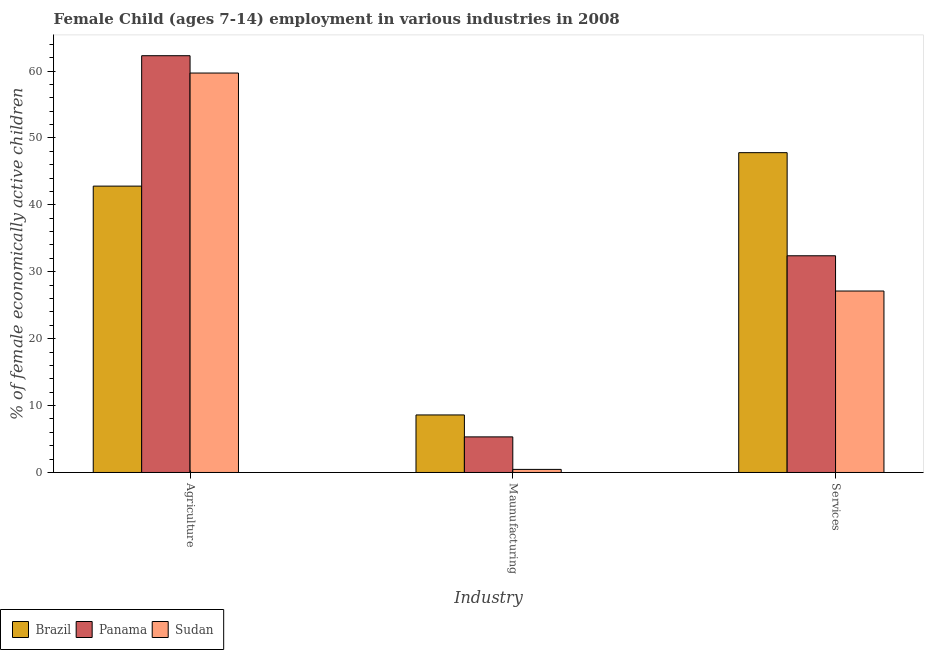How many different coloured bars are there?
Your response must be concise. 3. Are the number of bars on each tick of the X-axis equal?
Provide a short and direct response. Yes. How many bars are there on the 1st tick from the right?
Give a very brief answer. 3. What is the label of the 1st group of bars from the left?
Your response must be concise. Agriculture. What is the percentage of economically active children in services in Sudan?
Make the answer very short. 27.12. Across all countries, what is the maximum percentage of economically active children in manufacturing?
Offer a terse response. 8.6. Across all countries, what is the minimum percentage of economically active children in manufacturing?
Give a very brief answer. 0.46. In which country was the percentage of economically active children in manufacturing minimum?
Offer a very short reply. Sudan. What is the total percentage of economically active children in agriculture in the graph?
Your answer should be compact. 164.79. What is the difference between the percentage of economically active children in manufacturing in Sudan and that in Brazil?
Make the answer very short. -8.14. What is the difference between the percentage of economically active children in services in Brazil and the percentage of economically active children in manufacturing in Panama?
Your answer should be very brief. 42.48. What is the average percentage of economically active children in services per country?
Ensure brevity in your answer.  35.77. What is the difference between the percentage of economically active children in manufacturing and percentage of economically active children in agriculture in Brazil?
Provide a short and direct response. -34.2. What is the ratio of the percentage of economically active children in manufacturing in Sudan to that in Panama?
Provide a short and direct response. 0.09. Is the difference between the percentage of economically active children in agriculture in Sudan and Brazil greater than the difference between the percentage of economically active children in services in Sudan and Brazil?
Your answer should be very brief. Yes. What is the difference between the highest and the second highest percentage of economically active children in agriculture?
Ensure brevity in your answer.  2.59. What is the difference between the highest and the lowest percentage of economically active children in manufacturing?
Offer a terse response. 8.14. In how many countries, is the percentage of economically active children in manufacturing greater than the average percentage of economically active children in manufacturing taken over all countries?
Your answer should be very brief. 2. What does the 2nd bar from the right in Services represents?
Give a very brief answer. Panama. Is it the case that in every country, the sum of the percentage of economically active children in agriculture and percentage of economically active children in manufacturing is greater than the percentage of economically active children in services?
Provide a succinct answer. Yes. How many bars are there?
Ensure brevity in your answer.  9. What is the difference between two consecutive major ticks on the Y-axis?
Make the answer very short. 10. Does the graph contain any zero values?
Offer a terse response. No. Where does the legend appear in the graph?
Your answer should be very brief. Bottom left. How many legend labels are there?
Make the answer very short. 3. What is the title of the graph?
Offer a very short reply. Female Child (ages 7-14) employment in various industries in 2008. What is the label or title of the X-axis?
Your response must be concise. Industry. What is the label or title of the Y-axis?
Offer a terse response. % of female economically active children. What is the % of female economically active children of Brazil in Agriculture?
Your response must be concise. 42.8. What is the % of female economically active children in Panama in Agriculture?
Give a very brief answer. 62.29. What is the % of female economically active children of Sudan in Agriculture?
Your answer should be very brief. 59.7. What is the % of female economically active children of Brazil in Maunufacturing?
Offer a very short reply. 8.6. What is the % of female economically active children in Panama in Maunufacturing?
Give a very brief answer. 5.32. What is the % of female economically active children of Sudan in Maunufacturing?
Make the answer very short. 0.46. What is the % of female economically active children of Brazil in Services?
Keep it short and to the point. 47.8. What is the % of female economically active children of Panama in Services?
Offer a very short reply. 32.39. What is the % of female economically active children of Sudan in Services?
Ensure brevity in your answer.  27.12. Across all Industry, what is the maximum % of female economically active children in Brazil?
Your answer should be very brief. 47.8. Across all Industry, what is the maximum % of female economically active children in Panama?
Provide a succinct answer. 62.29. Across all Industry, what is the maximum % of female economically active children of Sudan?
Make the answer very short. 59.7. Across all Industry, what is the minimum % of female economically active children in Panama?
Make the answer very short. 5.32. Across all Industry, what is the minimum % of female economically active children of Sudan?
Keep it short and to the point. 0.46. What is the total % of female economically active children of Brazil in the graph?
Make the answer very short. 99.2. What is the total % of female economically active children of Sudan in the graph?
Offer a terse response. 87.28. What is the difference between the % of female economically active children of Brazil in Agriculture and that in Maunufacturing?
Your response must be concise. 34.2. What is the difference between the % of female economically active children in Panama in Agriculture and that in Maunufacturing?
Offer a terse response. 56.97. What is the difference between the % of female economically active children of Sudan in Agriculture and that in Maunufacturing?
Your answer should be compact. 59.24. What is the difference between the % of female economically active children of Brazil in Agriculture and that in Services?
Your answer should be very brief. -5. What is the difference between the % of female economically active children in Panama in Agriculture and that in Services?
Provide a short and direct response. 29.9. What is the difference between the % of female economically active children in Sudan in Agriculture and that in Services?
Make the answer very short. 32.58. What is the difference between the % of female economically active children of Brazil in Maunufacturing and that in Services?
Make the answer very short. -39.2. What is the difference between the % of female economically active children of Panama in Maunufacturing and that in Services?
Your response must be concise. -27.07. What is the difference between the % of female economically active children of Sudan in Maunufacturing and that in Services?
Your answer should be very brief. -26.66. What is the difference between the % of female economically active children in Brazil in Agriculture and the % of female economically active children in Panama in Maunufacturing?
Your answer should be compact. 37.48. What is the difference between the % of female economically active children in Brazil in Agriculture and the % of female economically active children in Sudan in Maunufacturing?
Offer a terse response. 42.34. What is the difference between the % of female economically active children in Panama in Agriculture and the % of female economically active children in Sudan in Maunufacturing?
Give a very brief answer. 61.83. What is the difference between the % of female economically active children in Brazil in Agriculture and the % of female economically active children in Panama in Services?
Ensure brevity in your answer.  10.41. What is the difference between the % of female economically active children in Brazil in Agriculture and the % of female economically active children in Sudan in Services?
Provide a short and direct response. 15.68. What is the difference between the % of female economically active children of Panama in Agriculture and the % of female economically active children of Sudan in Services?
Your response must be concise. 35.17. What is the difference between the % of female economically active children in Brazil in Maunufacturing and the % of female economically active children in Panama in Services?
Make the answer very short. -23.79. What is the difference between the % of female economically active children in Brazil in Maunufacturing and the % of female economically active children in Sudan in Services?
Your response must be concise. -18.52. What is the difference between the % of female economically active children in Panama in Maunufacturing and the % of female economically active children in Sudan in Services?
Offer a very short reply. -21.8. What is the average % of female economically active children in Brazil per Industry?
Give a very brief answer. 33.07. What is the average % of female economically active children of Panama per Industry?
Offer a terse response. 33.33. What is the average % of female economically active children of Sudan per Industry?
Provide a succinct answer. 29.09. What is the difference between the % of female economically active children of Brazil and % of female economically active children of Panama in Agriculture?
Provide a short and direct response. -19.49. What is the difference between the % of female economically active children in Brazil and % of female economically active children in Sudan in Agriculture?
Give a very brief answer. -16.9. What is the difference between the % of female economically active children in Panama and % of female economically active children in Sudan in Agriculture?
Provide a short and direct response. 2.59. What is the difference between the % of female economically active children of Brazil and % of female economically active children of Panama in Maunufacturing?
Your response must be concise. 3.28. What is the difference between the % of female economically active children in Brazil and % of female economically active children in Sudan in Maunufacturing?
Your response must be concise. 8.14. What is the difference between the % of female economically active children of Panama and % of female economically active children of Sudan in Maunufacturing?
Give a very brief answer. 4.86. What is the difference between the % of female economically active children of Brazil and % of female economically active children of Panama in Services?
Keep it short and to the point. 15.41. What is the difference between the % of female economically active children in Brazil and % of female economically active children in Sudan in Services?
Keep it short and to the point. 20.68. What is the difference between the % of female economically active children of Panama and % of female economically active children of Sudan in Services?
Provide a short and direct response. 5.27. What is the ratio of the % of female economically active children in Brazil in Agriculture to that in Maunufacturing?
Make the answer very short. 4.98. What is the ratio of the % of female economically active children of Panama in Agriculture to that in Maunufacturing?
Keep it short and to the point. 11.71. What is the ratio of the % of female economically active children in Sudan in Agriculture to that in Maunufacturing?
Provide a short and direct response. 129.78. What is the ratio of the % of female economically active children of Brazil in Agriculture to that in Services?
Provide a short and direct response. 0.9. What is the ratio of the % of female economically active children of Panama in Agriculture to that in Services?
Provide a short and direct response. 1.92. What is the ratio of the % of female economically active children in Sudan in Agriculture to that in Services?
Offer a terse response. 2.2. What is the ratio of the % of female economically active children in Brazil in Maunufacturing to that in Services?
Make the answer very short. 0.18. What is the ratio of the % of female economically active children of Panama in Maunufacturing to that in Services?
Your answer should be very brief. 0.16. What is the ratio of the % of female economically active children of Sudan in Maunufacturing to that in Services?
Provide a succinct answer. 0.02. What is the difference between the highest and the second highest % of female economically active children of Panama?
Offer a very short reply. 29.9. What is the difference between the highest and the second highest % of female economically active children of Sudan?
Provide a short and direct response. 32.58. What is the difference between the highest and the lowest % of female economically active children of Brazil?
Provide a succinct answer. 39.2. What is the difference between the highest and the lowest % of female economically active children of Panama?
Offer a terse response. 56.97. What is the difference between the highest and the lowest % of female economically active children of Sudan?
Offer a very short reply. 59.24. 